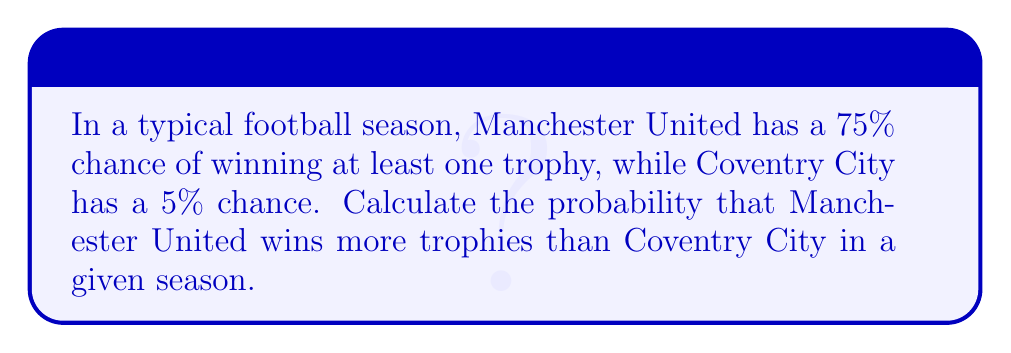Provide a solution to this math problem. Let's approach this step-by-step:

1) First, we need to consider all possible scenarios:
   a) Manchester United wins at least one trophy, Coventry City wins none
   b) Both teams win at least one trophy
   c) Neither team wins a trophy
   d) Coventry City wins at least one trophy, Manchester United wins none

2) We're interested in scenario (a), as this is the only case where Manchester United definitely wins more trophies than Coventry City.

3) Let's calculate the probability of this scenario:
   
   $P(\text{MU wins, Coventry doesn't}) = P(\text{MU wins}) \times P(\text{Coventry doesn't win})$

4) We know:
   $P(\text{MU wins}) = 0.75$
   $P(\text{Coventry doesn't win}) = 1 - P(\text{Coventry wins}) = 1 - 0.05 = 0.95$

5) Substituting these values:

   $P(\text{MU wins, Coventry doesn't}) = 0.75 \times 0.95 = 0.7125$

6) Therefore, the probability that Manchester United wins more trophies than Coventry City is 0.7125 or 71.25%.
Answer: 0.7125 